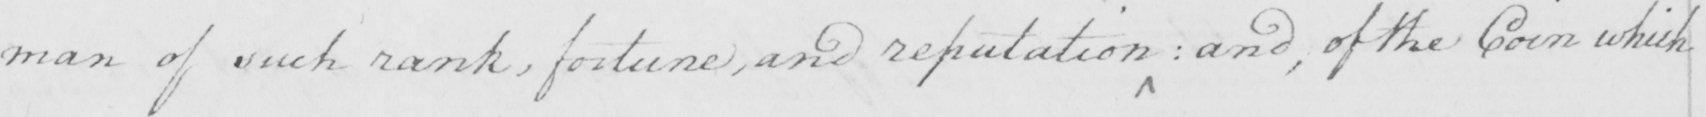Can you read and transcribe this handwriting? man of such rank , fortune , and reputation  :  and , of the Coin which 